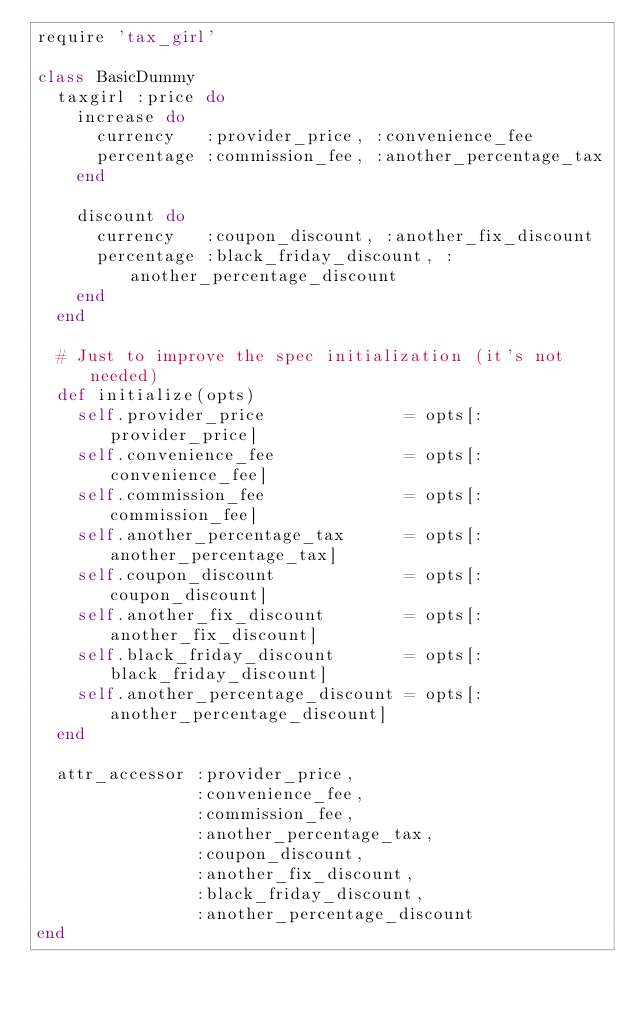Convert code to text. <code><loc_0><loc_0><loc_500><loc_500><_Ruby_>require 'tax_girl'

class BasicDummy
  taxgirl :price do
    increase do
      currency   :provider_price, :convenience_fee
      percentage :commission_fee, :another_percentage_tax
    end

    discount do
      currency   :coupon_discount, :another_fix_discount
      percentage :black_friday_discount, :another_percentage_discount
    end
  end

  # Just to improve the spec initialization (it's not needed)
  def initialize(opts)
    self.provider_price              = opts[:provider_price]
    self.convenience_fee             = opts[:convenience_fee]
    self.commission_fee              = opts[:commission_fee]
    self.another_percentage_tax      = opts[:another_percentage_tax]
    self.coupon_discount             = opts[:coupon_discount]
    self.another_fix_discount        = opts[:another_fix_discount]
    self.black_friday_discount       = opts[:black_friday_discount]
    self.another_percentage_discount = opts[:another_percentage_discount]
  end

  attr_accessor :provider_price,
                :convenience_fee,
                :commission_fee,
                :another_percentage_tax,
                :coupon_discount,
                :another_fix_discount,
                :black_friday_discount,
                :another_percentage_discount
end
</code> 